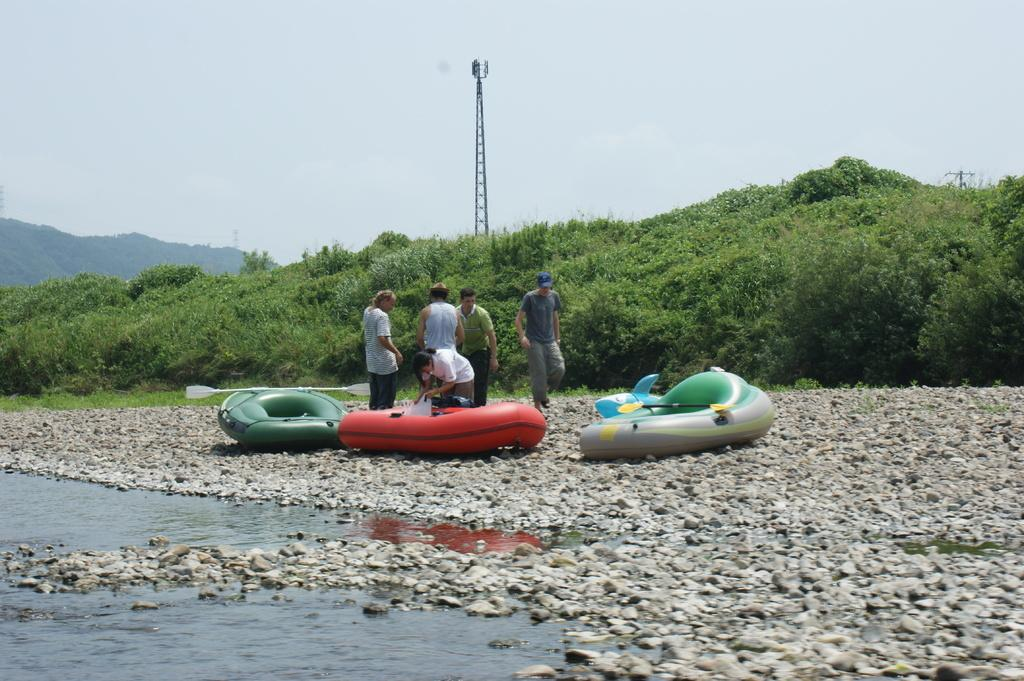What can be seen in the foreground of the image? In the foreground of the image, there are people, rafts, stones, and oars. What is the primary element in the foreground? Water is visible in the foreground of the image. What can be seen in the background of the image? In the background of the image, there are trees, poles, a mountain, and the sky. How many different elements can be seen in the foreground? There are five different elements in the foreground: people, rafts, stones, oars, and water. What type of behavior can be observed in the lake in the image? There is no lake present in the image; it features water in the foreground. What is the taste of the water in the image? The taste of the water cannot be determined from the image. 